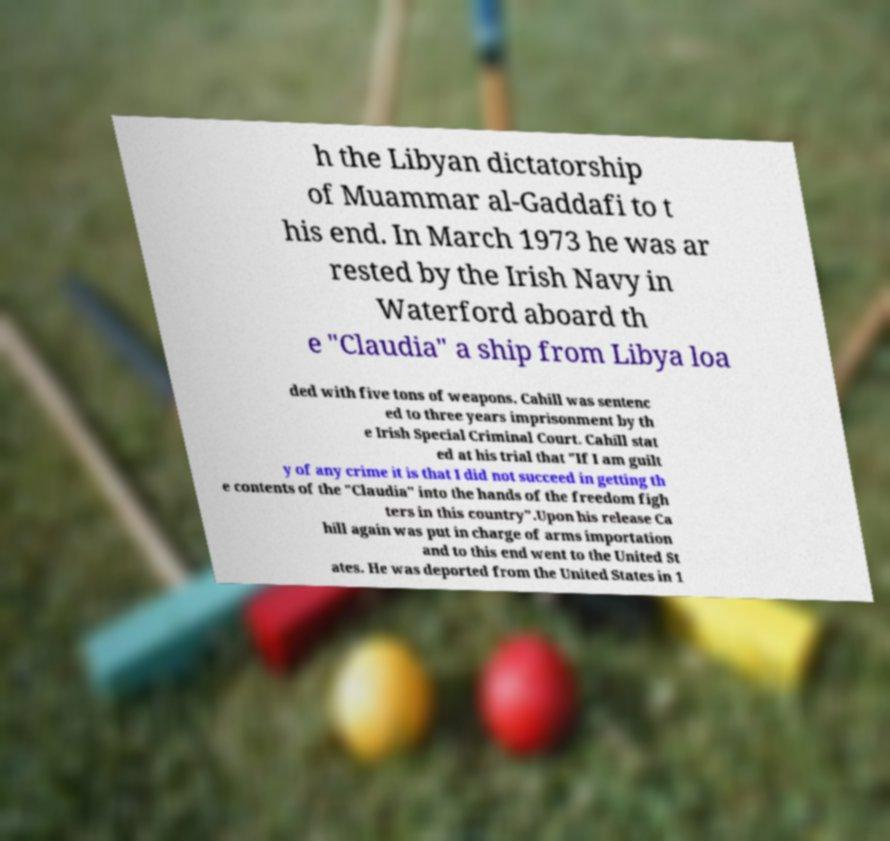I need the written content from this picture converted into text. Can you do that? h the Libyan dictatorship of Muammar al-Gaddafi to t his end. In March 1973 he was ar rested by the Irish Navy in Waterford aboard th e "Claudia" a ship from Libya loa ded with five tons of weapons. Cahill was sentenc ed to three years imprisonment by th e Irish Special Criminal Court. Cahill stat ed at his trial that "If I am guilt y of any crime it is that I did not succeed in getting th e contents of the "Claudia" into the hands of the freedom figh ters in this country".Upon his release Ca hill again was put in charge of arms importation and to this end went to the United St ates. He was deported from the United States in 1 